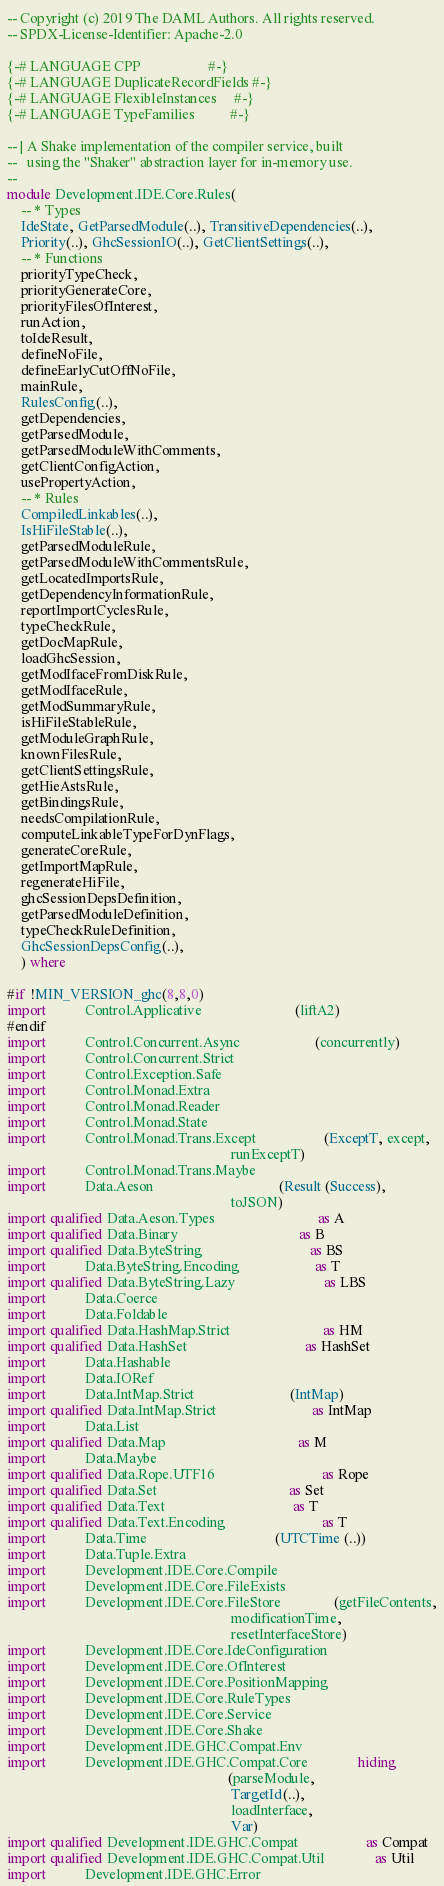<code> <loc_0><loc_0><loc_500><loc_500><_Haskell_>-- Copyright (c) 2019 The DAML Authors. All rights reserved.
-- SPDX-License-Identifier: Apache-2.0

{-# LANGUAGE CPP                   #-}
{-# LANGUAGE DuplicateRecordFields #-}
{-# LANGUAGE FlexibleInstances     #-}
{-# LANGUAGE TypeFamilies          #-}

-- | A Shake implementation of the compiler service, built
--   using the "Shaker" abstraction layer for in-memory use.
--
module Development.IDE.Core.Rules(
    -- * Types
    IdeState, GetParsedModule(..), TransitiveDependencies(..),
    Priority(..), GhcSessionIO(..), GetClientSettings(..),
    -- * Functions
    priorityTypeCheck,
    priorityGenerateCore,
    priorityFilesOfInterest,
    runAction,
    toIdeResult,
    defineNoFile,
    defineEarlyCutOffNoFile,
    mainRule,
    RulesConfig(..),
    getDependencies,
    getParsedModule,
    getParsedModuleWithComments,
    getClientConfigAction,
    usePropertyAction,
    -- * Rules
    CompiledLinkables(..),
    IsHiFileStable(..),
    getParsedModuleRule,
    getParsedModuleWithCommentsRule,
    getLocatedImportsRule,
    getDependencyInformationRule,
    reportImportCyclesRule,
    typeCheckRule,
    getDocMapRule,
    loadGhcSession,
    getModIfaceFromDiskRule,
    getModIfaceRule,
    getModSummaryRule,
    isHiFileStableRule,
    getModuleGraphRule,
    knownFilesRule,
    getClientSettingsRule,
    getHieAstsRule,
    getBindingsRule,
    needsCompilationRule,
    computeLinkableTypeForDynFlags,
    generateCoreRule,
    getImportMapRule,
    regenerateHiFile,
    ghcSessionDepsDefinition,
    getParsedModuleDefinition,
    typeCheckRuleDefinition,
    GhcSessionDepsConfig(..),
    ) where

#if !MIN_VERSION_ghc(8,8,0)
import           Control.Applicative                          (liftA2)
#endif
import           Control.Concurrent.Async                     (concurrently)
import           Control.Concurrent.Strict
import           Control.Exception.Safe
import           Control.Monad.Extra
import           Control.Monad.Reader
import           Control.Monad.State
import           Control.Monad.Trans.Except                   (ExceptT, except,
                                                               runExceptT)
import           Control.Monad.Trans.Maybe
import           Data.Aeson                                   (Result (Success),
                                                               toJSON)
import qualified Data.Aeson.Types                             as A
import qualified Data.Binary                                  as B
import qualified Data.ByteString                              as BS
import           Data.ByteString.Encoding                     as T
import qualified Data.ByteString.Lazy                         as LBS
import           Data.Coerce
import           Data.Foldable
import qualified Data.HashMap.Strict                          as HM
import qualified Data.HashSet                                 as HashSet
import           Data.Hashable
import           Data.IORef
import           Data.IntMap.Strict                           (IntMap)
import qualified Data.IntMap.Strict                           as IntMap
import           Data.List
import qualified Data.Map                                     as M
import           Data.Maybe
import qualified Data.Rope.UTF16                              as Rope
import qualified Data.Set                                     as Set
import qualified Data.Text                                    as T
import qualified Data.Text.Encoding                           as T
import           Data.Time                                    (UTCTime (..))
import           Data.Tuple.Extra
import           Development.IDE.Core.Compile
import           Development.IDE.Core.FileExists
import           Development.IDE.Core.FileStore               (getFileContents,
                                                               modificationTime,
                                                               resetInterfaceStore)
import           Development.IDE.Core.IdeConfiguration
import           Development.IDE.Core.OfInterest
import           Development.IDE.Core.PositionMapping
import           Development.IDE.Core.RuleTypes
import           Development.IDE.Core.Service
import           Development.IDE.Core.Shake
import           Development.IDE.GHC.Compat.Env
import           Development.IDE.GHC.Compat.Core              hiding
                                                              (parseModule,
                                                               TargetId(..),
                                                               loadInterface,
                                                               Var)
import qualified Development.IDE.GHC.Compat                   as Compat
import qualified Development.IDE.GHC.Compat.Util              as Util
import           Development.IDE.GHC.Error</code> 